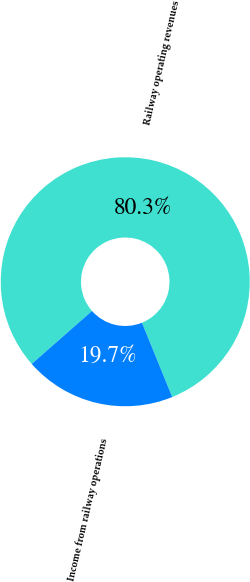Convert chart. <chart><loc_0><loc_0><loc_500><loc_500><pie_chart><fcel>Railway operating revenues<fcel>Income from railway operations<nl><fcel>80.32%<fcel>19.68%<nl></chart> 